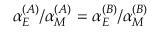<formula> <loc_0><loc_0><loc_500><loc_500>\alpha _ { E } ^ { ( A ) } / \alpha _ { M } ^ { ( A ) } = \alpha _ { E } ^ { ( B ) } / \alpha _ { M } ^ { ( B ) }</formula> 